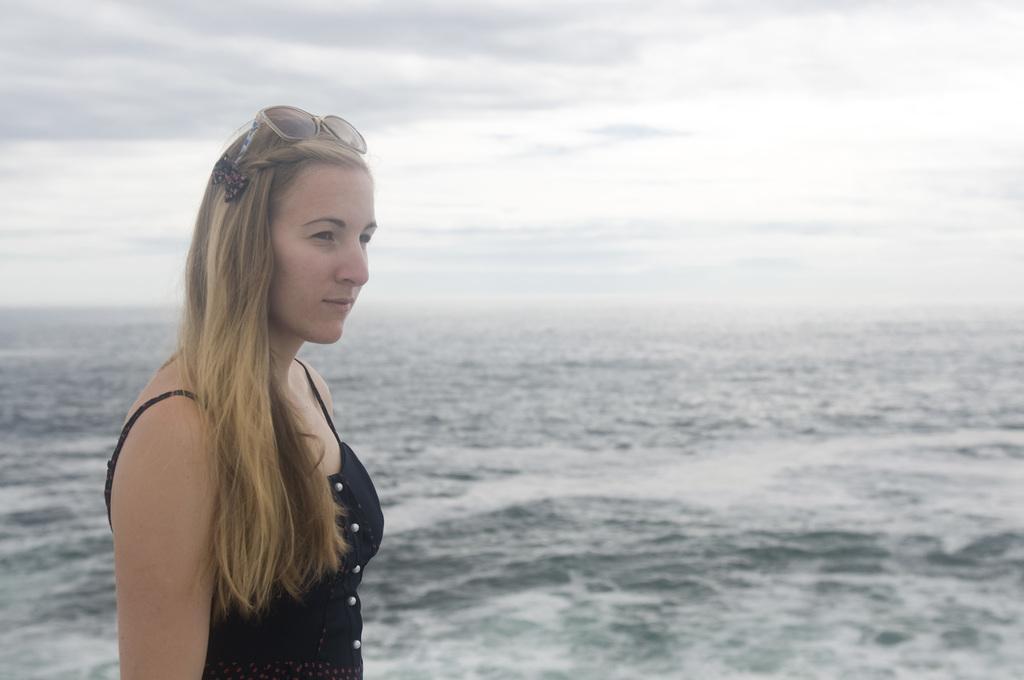Please provide a concise description of this image. In this image we can see a lady standing. She is wearing a black dress. In the background there is a sea and sky. 